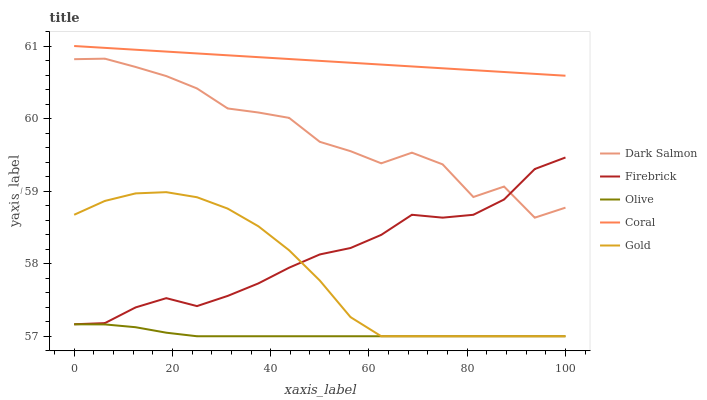Does Olive have the minimum area under the curve?
Answer yes or no. Yes. Does Coral have the maximum area under the curve?
Answer yes or no. Yes. Does Firebrick have the minimum area under the curve?
Answer yes or no. No. Does Firebrick have the maximum area under the curve?
Answer yes or no. No. Is Coral the smoothest?
Answer yes or no. Yes. Is Dark Salmon the roughest?
Answer yes or no. Yes. Is Firebrick the smoothest?
Answer yes or no. No. Is Firebrick the roughest?
Answer yes or no. No. Does Olive have the lowest value?
Answer yes or no. Yes. Does Firebrick have the lowest value?
Answer yes or no. No. Does Coral have the highest value?
Answer yes or no. Yes. Does Firebrick have the highest value?
Answer yes or no. No. Is Gold less than Coral?
Answer yes or no. Yes. Is Firebrick greater than Olive?
Answer yes or no. Yes. Does Olive intersect Gold?
Answer yes or no. Yes. Is Olive less than Gold?
Answer yes or no. No. Is Olive greater than Gold?
Answer yes or no. No. Does Gold intersect Coral?
Answer yes or no. No. 